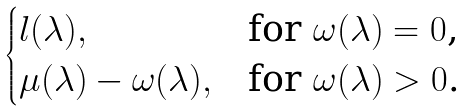Convert formula to latex. <formula><loc_0><loc_0><loc_500><loc_500>\begin{cases} l ( \lambda ) , & \text {for $\omega(\lambda)=0$,} \\ \mu ( \lambda ) - \omega ( \lambda ) , & \text {for $\omega(\lambda)>0$.} \end{cases}</formula> 